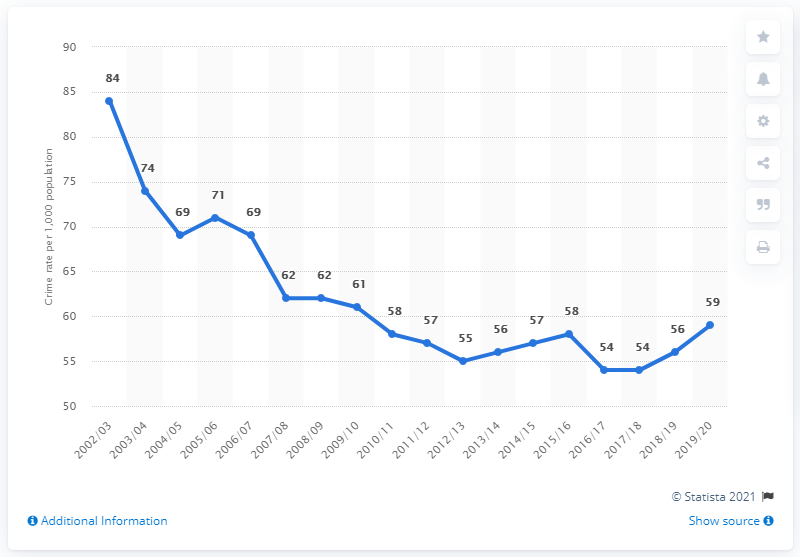What trend does the crime rate in Northern Ireland show over the years? The chart reveals a general downward trend in the crime rate in Northern Ireland from early 2003 through to around 2012/13, with the highest rate recorded at 84 incidents per 1,000 population in 2003/04. Following this peak, there is a fluctuation with slight increases and decreases over the years, but the overall trend appears to stabilize toward the end of the period shown, with rates hovering just above 50 incidents per 1,000 population. 